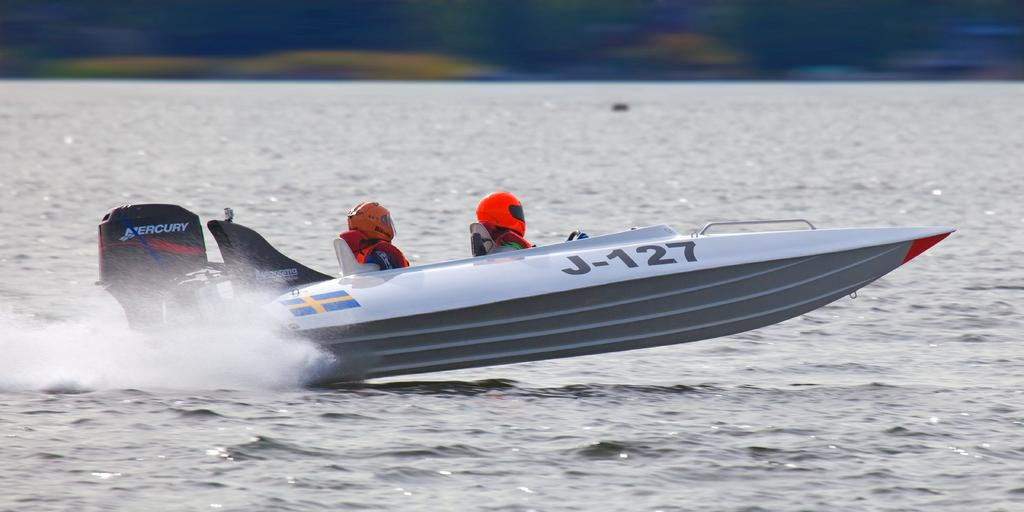<image>
Offer a succinct explanation of the picture presented. A boat has J-127 printed on its side. 